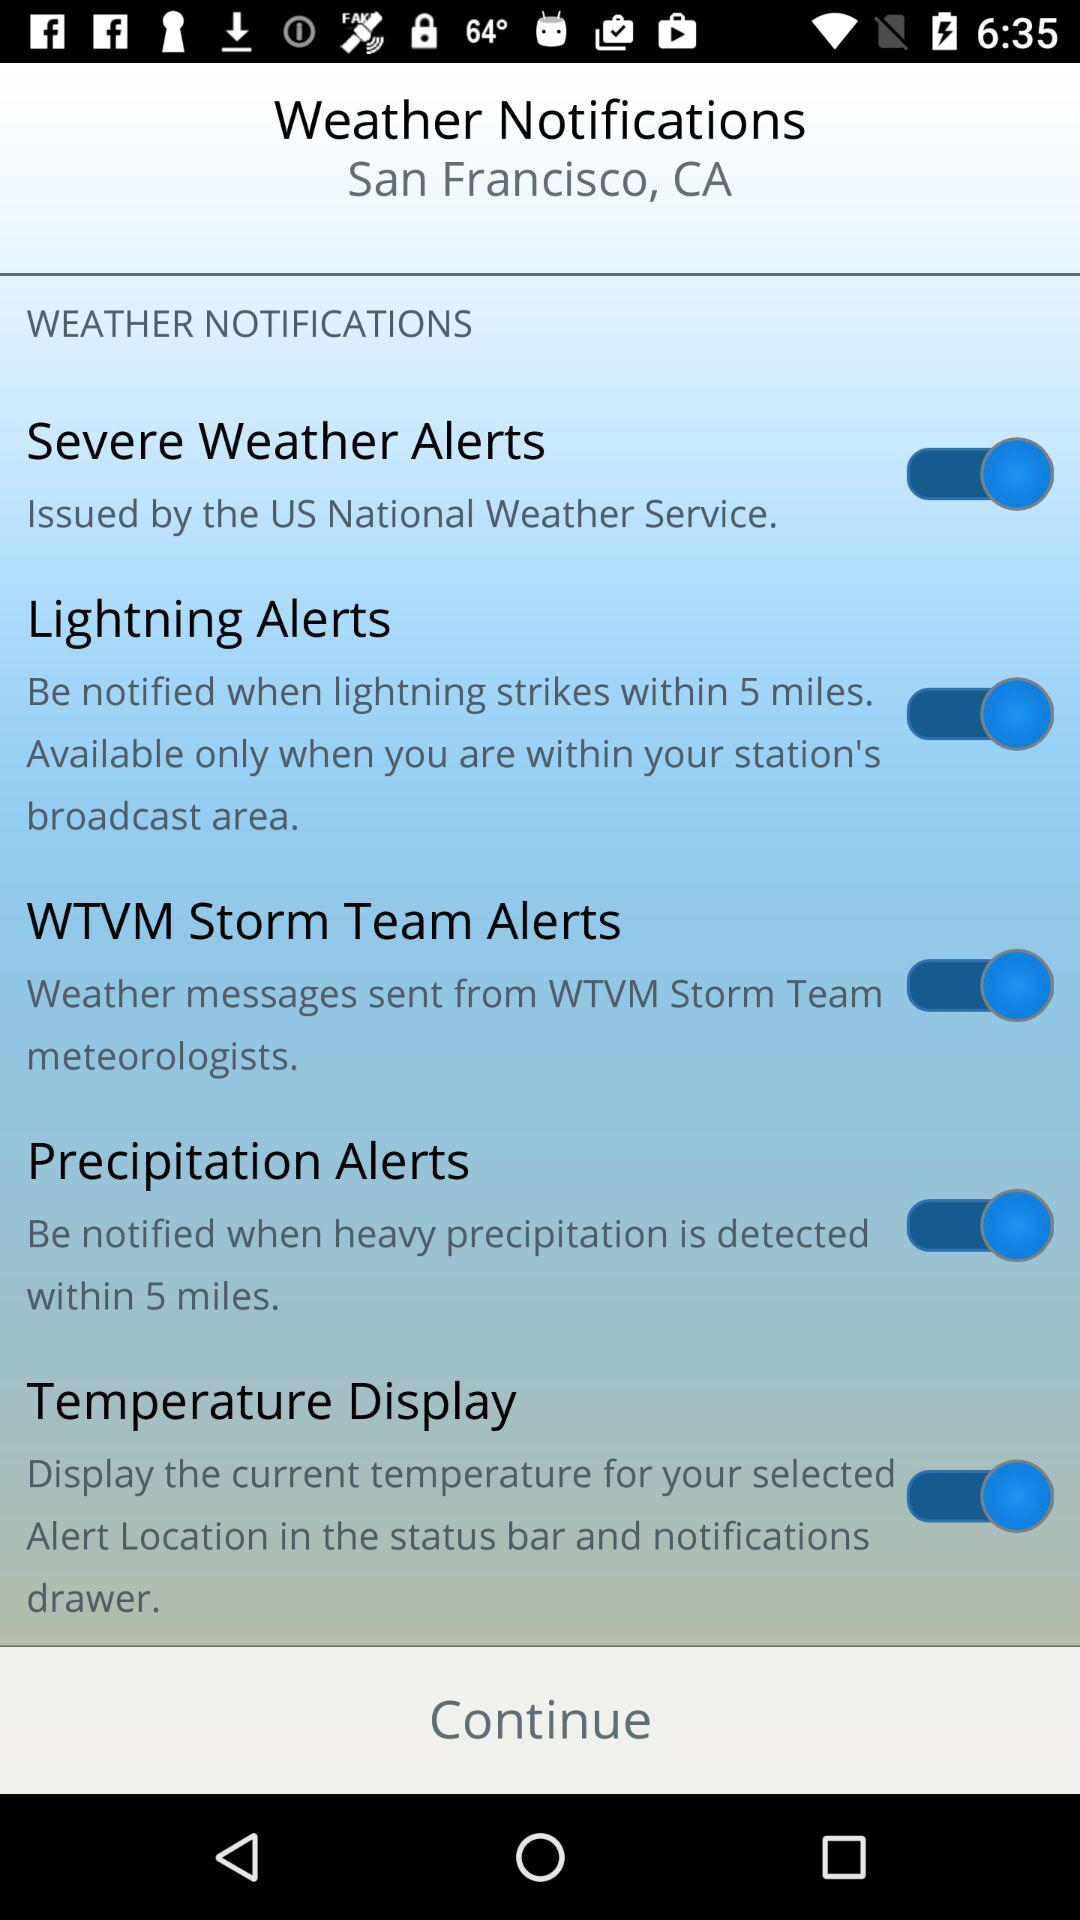Which are the different weather notifications? The different weather notifications are "Severe Weather Alerts", "Lightning Alerts", "WTVM Storm Team Alerts", "Precipitation Alerts" and "Temperature Display". 